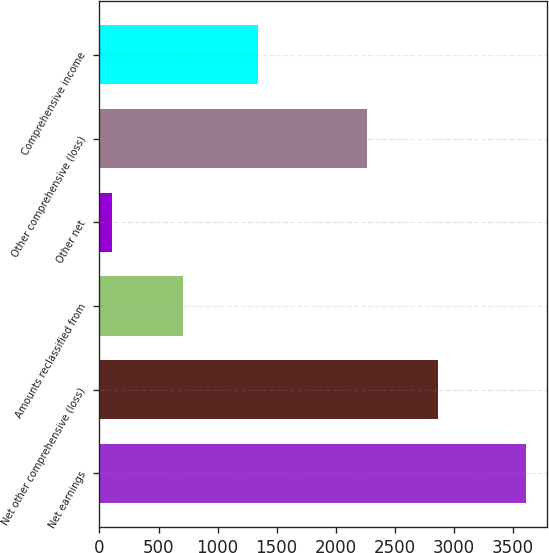Convert chart to OTSL. <chart><loc_0><loc_0><loc_500><loc_500><bar_chart><fcel>Net earnings<fcel>Net other comprehensive (loss)<fcel>Amounts reclassified from<fcel>Other net<fcel>Other comprehensive (loss)<fcel>Comprehensive income<nl><fcel>3614<fcel>2870<fcel>706<fcel>105<fcel>2269<fcel>1345<nl></chart> 